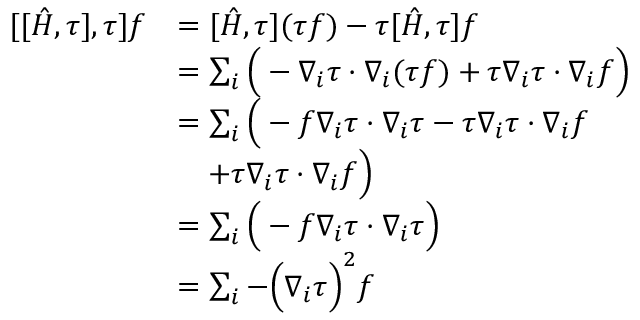<formula> <loc_0><loc_0><loc_500><loc_500>\begin{array} { r l } { [ [ \hat { H } , \tau ] , \tau ] f } & { = [ \hat { H } , \tau ] ( \tau f ) - \tau [ \hat { H } , \tau ] f } \\ & { = \sum _ { i } \left ( - \nabla _ { i } \tau \cdot \nabla _ { i } ( \tau f ) + \tau \nabla _ { i } \boldsymbol \tau \cdot \nabla _ { i } f \right ) } \\ & { = \sum _ { i } \left ( - f \nabla _ { i } \tau \cdot \nabla _ { i } \tau - \tau \nabla _ { i } \tau \cdot \nabla _ { i } f } \\ & { \quad + \tau \nabla _ { i } \tau \cdot \nabla _ { i } f \right ) } \\ & { = \sum _ { i } \left ( - f \nabla _ { i } \tau \cdot \nabla _ { i } \tau \right ) } \\ & { = \sum _ { i } - \left ( \nabla _ { i } \tau \right ) ^ { 2 } f } \end{array}</formula> 